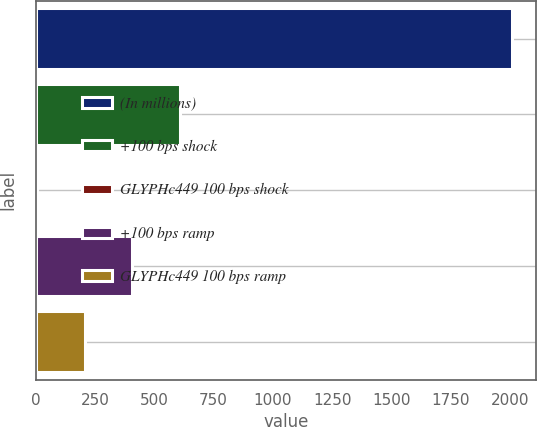Convert chart. <chart><loc_0><loc_0><loc_500><loc_500><bar_chart><fcel>(In millions)<fcel>+100 bps shock<fcel>GLYPHc449 100 bps shock<fcel>+100 bps ramp<fcel>GLYPHc449 100 bps ramp<nl><fcel>2007<fcel>607<fcel>7<fcel>407<fcel>207<nl></chart> 